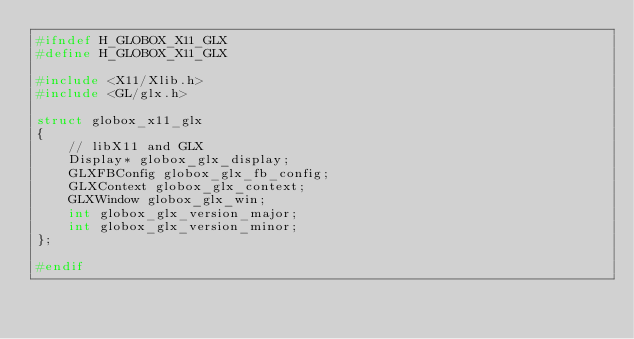<code> <loc_0><loc_0><loc_500><loc_500><_C_>#ifndef H_GLOBOX_X11_GLX
#define H_GLOBOX_X11_GLX

#include <X11/Xlib.h>
#include <GL/glx.h>

struct globox_x11_glx
{
	// libX11 and GLX
	Display* globox_glx_display;
	GLXFBConfig globox_glx_fb_config;
	GLXContext globox_glx_context;
	GLXWindow globox_glx_win;
	int globox_glx_version_major;
	int globox_glx_version_minor;
};

#endif
</code> 